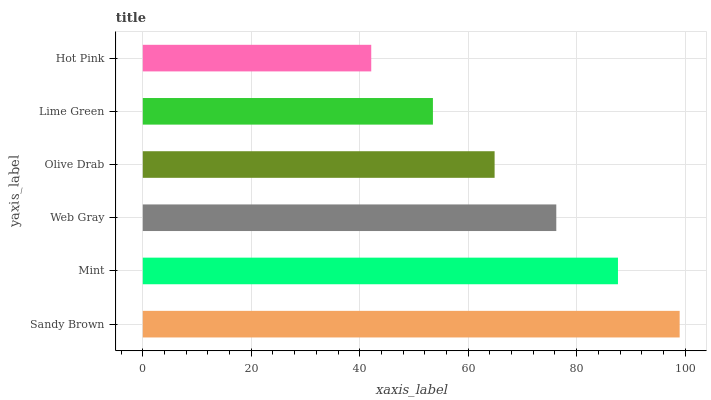Is Hot Pink the minimum?
Answer yes or no. Yes. Is Sandy Brown the maximum?
Answer yes or no. Yes. Is Mint the minimum?
Answer yes or no. No. Is Mint the maximum?
Answer yes or no. No. Is Sandy Brown greater than Mint?
Answer yes or no. Yes. Is Mint less than Sandy Brown?
Answer yes or no. Yes. Is Mint greater than Sandy Brown?
Answer yes or no. No. Is Sandy Brown less than Mint?
Answer yes or no. No. Is Web Gray the high median?
Answer yes or no. Yes. Is Olive Drab the low median?
Answer yes or no. Yes. Is Mint the high median?
Answer yes or no. No. Is Mint the low median?
Answer yes or no. No. 